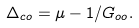Convert formula to latex. <formula><loc_0><loc_0><loc_500><loc_500>\Delta _ { c o } = \mu - 1 / G _ { o o } .</formula> 